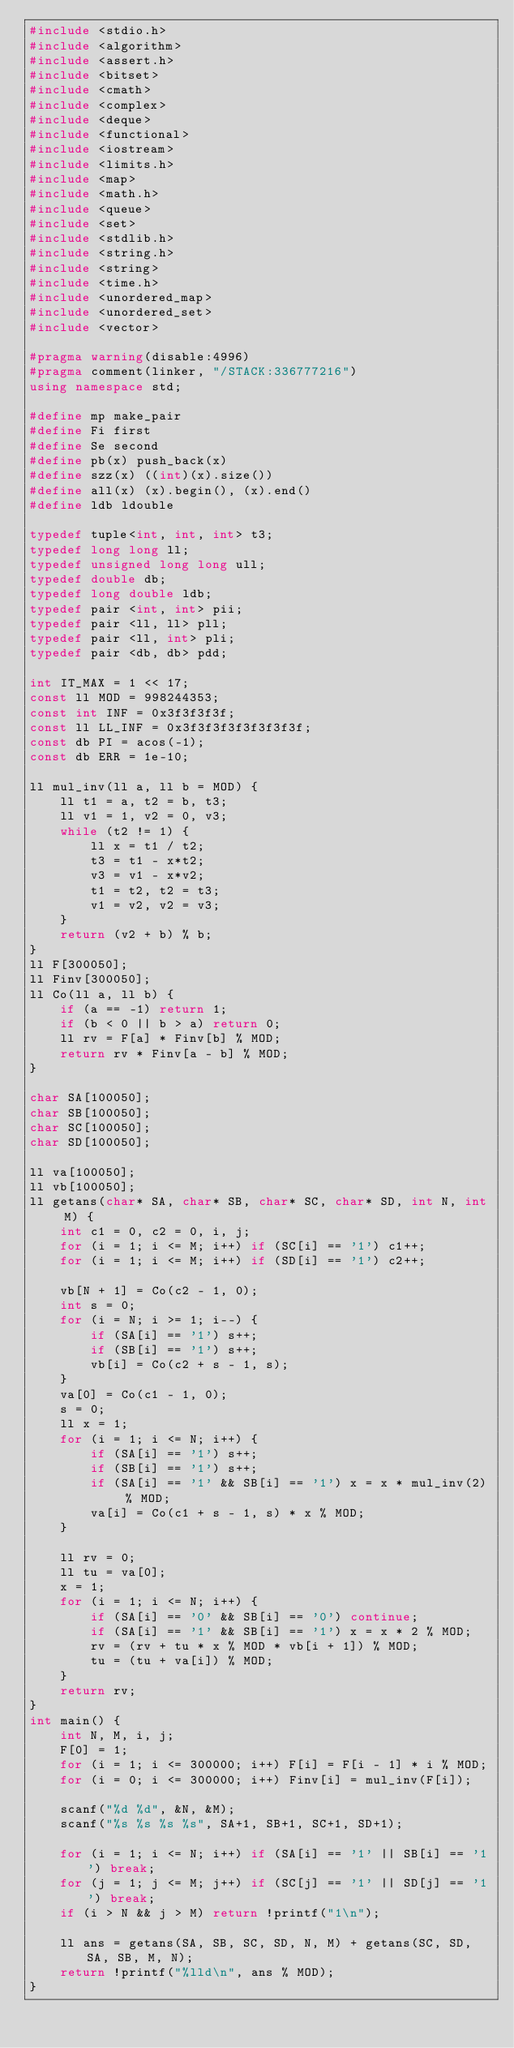<code> <loc_0><loc_0><loc_500><loc_500><_C++_>#include <stdio.h>  
#include <algorithm>  
#include <assert.h>
#include <bitset>
#include <cmath>  
#include <complex>  
#include <deque>  
#include <functional>  
#include <iostream>  
#include <limits.h>  
#include <map>  
#include <math.h>  
#include <queue>  
#include <set>  
#include <stdlib.h>  
#include <string.h>  
#include <string>  
#include <time.h>  
#include <unordered_map>  
#include <unordered_set>  
#include <vector>

#pragma warning(disable:4996)  
#pragma comment(linker, "/STACK:336777216")  
using namespace std;

#define mp make_pair  
#define Fi first  
#define Se second  
#define pb(x) push_back(x)  
#define szz(x) ((int)(x).size()) 
#define all(x) (x).begin(), (x).end()  
#define ldb ldouble  

typedef tuple<int, int, int> t3;
typedef long long ll;
typedef unsigned long long ull;
typedef double db;
typedef long double ldb;
typedef pair <int, int> pii;
typedef pair <ll, ll> pll;
typedef pair <ll, int> pli;
typedef pair <db, db> pdd;

int IT_MAX = 1 << 17;
const ll MOD = 998244353;
const int INF = 0x3f3f3f3f;
const ll LL_INF = 0x3f3f3f3f3f3f3f3f;
const db PI = acos(-1);
const db ERR = 1e-10;

ll mul_inv(ll a, ll b = MOD) {
	ll t1 = a, t2 = b, t3;
	ll v1 = 1, v2 = 0, v3;
	while (t2 != 1) {
		ll x = t1 / t2;
		t3 = t1 - x*t2;
		v3 = v1 - x*v2;
		t1 = t2, t2 = t3;
		v1 = v2, v2 = v3;
	}
	return (v2 + b) % b;
}
ll F[300050];
ll Finv[300050];
ll Co(ll a, ll b) {
	if (a == -1) return 1;
	if (b < 0 || b > a) return 0;
	ll rv = F[a] * Finv[b] % MOD;
	return rv * Finv[a - b] % MOD;
}

char SA[100050];
char SB[100050];
char SC[100050];
char SD[100050];

ll va[100050];
ll vb[100050];
ll getans(char* SA, char* SB, char* SC, char* SD, int N, int M) {
	int c1 = 0, c2 = 0, i, j;
	for (i = 1; i <= M; i++) if (SC[i] == '1') c1++;
	for (i = 1; i <= M; i++) if (SD[i] == '1') c2++;

	vb[N + 1] = Co(c2 - 1, 0);
	int s = 0;
	for (i = N; i >= 1; i--) {
		if (SA[i] == '1') s++;
		if (SB[i] == '1') s++;
		vb[i] = Co(c2 + s - 1, s);
	}
	va[0] = Co(c1 - 1, 0);
	s = 0;
	ll x = 1;
	for (i = 1; i <= N; i++) {
		if (SA[i] == '1') s++;
		if (SB[i] == '1') s++;
		if (SA[i] == '1' && SB[i] == '1') x = x * mul_inv(2) % MOD;
		va[i] = Co(c1 + s - 1, s) * x % MOD;
	}

	ll rv = 0;
	ll tu = va[0];
	x = 1;
	for (i = 1; i <= N; i++) {
		if (SA[i] == '0' && SB[i] == '0') continue;
		if (SA[i] == '1' && SB[i] == '1') x = x * 2 % MOD;
		rv = (rv + tu * x % MOD * vb[i + 1]) % MOD;
		tu = (tu + va[i]) % MOD;
	}
	return rv;
}
int main() {
	int N, M, i, j;
	F[0] = 1;
	for (i = 1; i <= 300000; i++) F[i] = F[i - 1] * i % MOD;
	for (i = 0; i <= 300000; i++) Finv[i] = mul_inv(F[i]);

	scanf("%d %d", &N, &M);
	scanf("%s %s %s %s", SA+1, SB+1, SC+1, SD+1);
	
	for (i = 1; i <= N; i++) if (SA[i] == '1' || SB[i] == '1') break;
	for (j = 1; j <= M; j++) if (SC[j] == '1' || SD[j] == '1') break;
	if (i > N && j > M) return !printf("1\n");

	ll ans = getans(SA, SB, SC, SD, N, M) + getans(SC, SD, SA, SB, M, N);
	return !printf("%lld\n", ans % MOD);
}</code> 